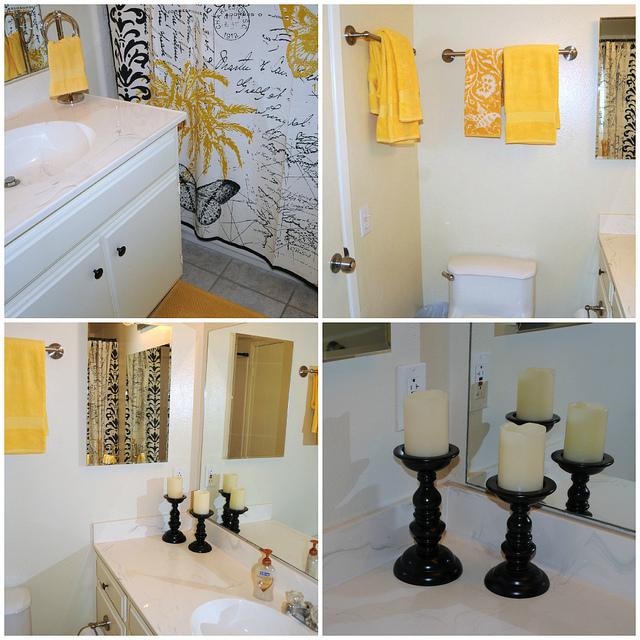Is this all one picture?
Short answer required. No. Is a person able to wash their hands in this room?
Be succinct. Yes. How many candles are in the bathroom?
Quick response, please. 2. 